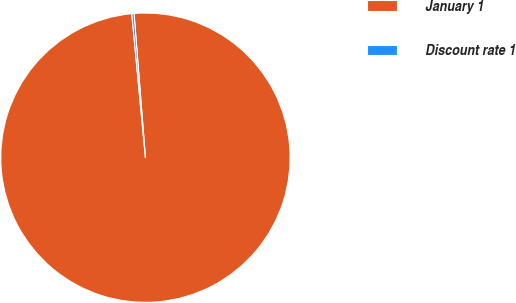Convert chart to OTSL. <chart><loc_0><loc_0><loc_500><loc_500><pie_chart><fcel>January 1<fcel>Discount rate 1<nl><fcel>99.75%<fcel>0.25%<nl></chart> 